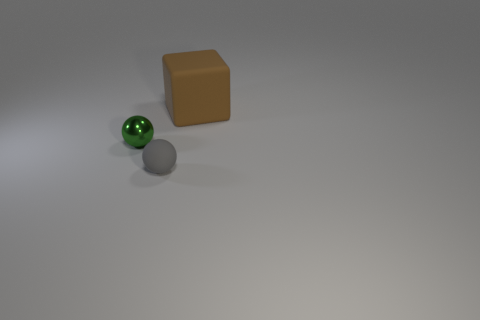Add 1 rubber spheres. How many objects exist? 4 Subtract 2 balls. How many balls are left? 0 Subtract all balls. How many objects are left? 1 Add 2 shiny objects. How many shiny objects are left? 3 Add 2 green objects. How many green objects exist? 3 Subtract 1 gray spheres. How many objects are left? 2 Subtract all blue blocks. Subtract all red balls. How many blocks are left? 1 Subtract all big yellow balls. Subtract all tiny objects. How many objects are left? 1 